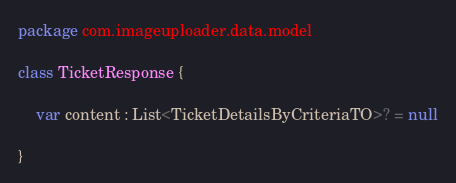<code> <loc_0><loc_0><loc_500><loc_500><_Kotlin_>package com.imageuploader.data.model

class TicketResponse {

    var content : List<TicketDetailsByCriteriaTO>? = null

}</code> 